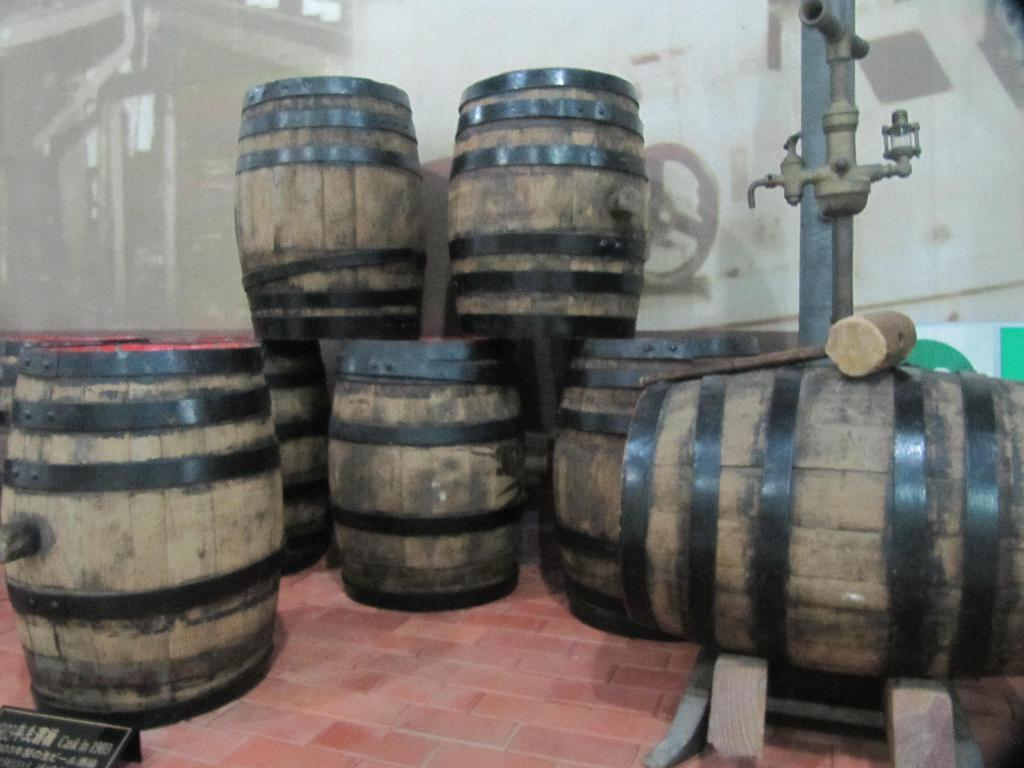What type of containers are visible in the image? There are wooden barrels in the image. How are the wooden barrels positioned in the image? The wooden barrels are placed on a surface. What other object can be seen in the image? There is a name board in the image. What is the purpose of the rod with a tap in the image? The rod with a tap is likely used for dispensing liquid from the wooden barrels. What is visible in the background of the image? There is a wall in the background of the image. What type of toy is being transported in the quiver in the image? There is no toy or quiver present in the image. 